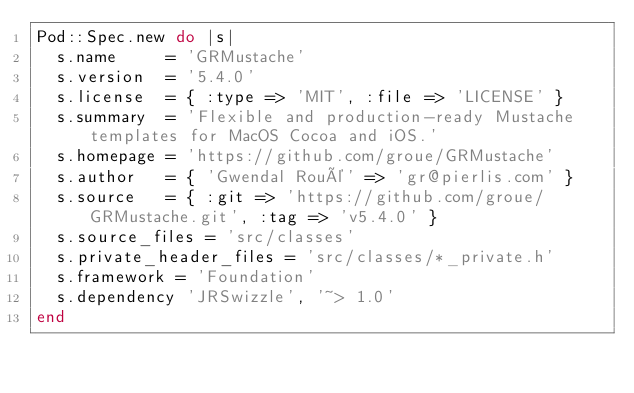Convert code to text. <code><loc_0><loc_0><loc_500><loc_500><_Ruby_>Pod::Spec.new do |s|
  s.name     = 'GRMustache'
  s.version  = '5.4.0'
  s.license  = { :type => 'MIT', :file => 'LICENSE' }
  s.summary  = 'Flexible and production-ready Mustache templates for MacOS Cocoa and iOS.'
  s.homepage = 'https://github.com/groue/GRMustache'
  s.author   = { 'Gwendal Roué' => 'gr@pierlis.com' }
  s.source   = { :git => 'https://github.com/groue/GRMustache.git', :tag => 'v5.4.0' }
  s.source_files = 'src/classes'
  s.private_header_files = 'src/classes/*_private.h'
  s.framework = 'Foundation'
  s.dependency 'JRSwizzle', '~> 1.0'
end
</code> 